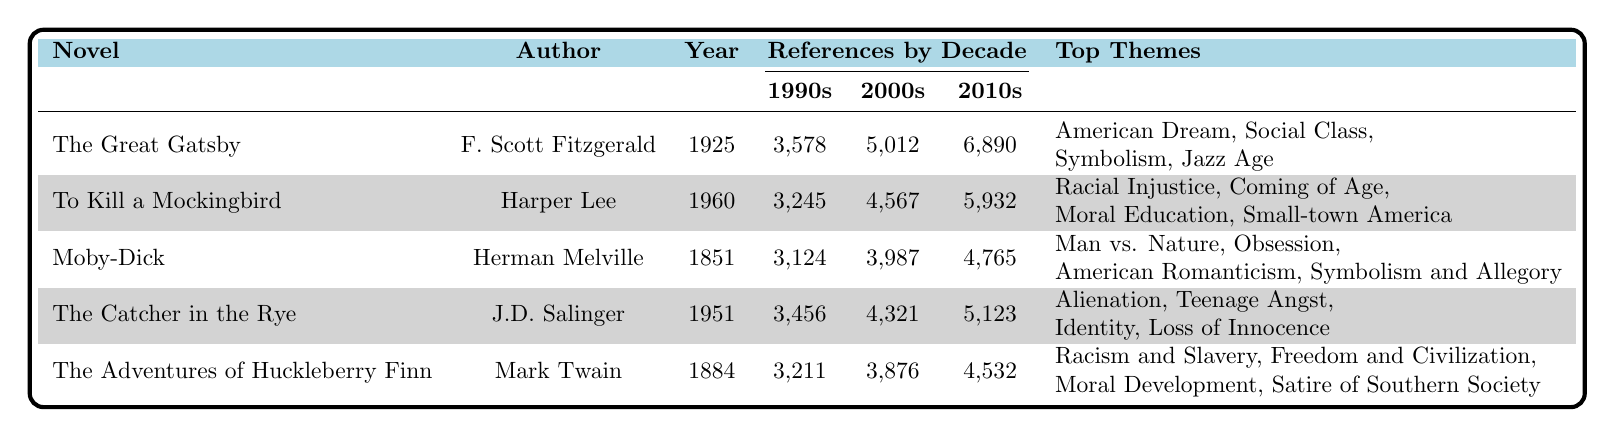What is the title of the novel with the most references in the 2010s? By examining the "References by Decade" section for the 2010s, "The Great Gatsby" has the highest count with 6,890 academic papers referencing it.
Answer: The Great Gatsby Which novel had the fewest references in the 1970s? Looking at the 1970s references, "To Kill a Mockingbird" had 987 academic papers, which is the lowest compared to the other novels listed.
Answer: To Kill a Mockingbird What are the top themes analyzed for "Moby-Dick"? Under the "Top Themes Analyzed" for "Moby-Dick," they include "Man vs. Nature," "Obsession," "American Romanticism," and "Symbolism and Allegory."
Answer: Man vs. Nature, Obsession, American Romanticism, Symbolism and Allegory How many more references did "To Kill a Mockingbird" receive in the 1990s than in the 1970s? In the 1990s, "To Kill a Mockingbird" had 3,245 academic papers compared to 987 in the 1970s. Therefore, the difference is 3,245 - 987 = 2,258.
Answer: 2258 Which novel experienced the highest increase in references from the 1990s to the 2010s? The increase for each novel can be calculated as follows: "The Great Gatsby" (6,890 - 3,578 = 3,312), "To Kill a Mockingbird" (5,932 - 3,245 = 2,687), "Moby-Dick" (4,765 - 3,124 = 1,641), "The Catcher in the Rye" (5,123 - 3,456 = 1,667), and "The Adventures of Huckleberry Finn" (4,532 - 3,211 = 1,321). "The Great Gatsby" had the highest increase of 3,312 references.
Answer: The Great Gatsby What is the total number of academic references for "The Catcher in the Rye" across all decades? Summing up the references from each decade gives: 3,456 + 4,321 + 5,123 = 12,900 academic papers for "The Catcher in the Rye."
Answer: 12,900 Is the theme "Racial Injustice" analyzed in "Moby-Dick"? The analyzed themes for "Moby-Dick" do not include "Racial Injustice," as the themes are focused on nature, obsession, and romanticism.
Answer: No Which author's works received more references in the 2010s, Harpers Lee or J.D. Salinger? Looking at the references for the 2010s, Harper Lee had 5,932 references, while J.D. Salinger had 5,123. Since 5,932 > 5,123, Harper Lee's works received more references.
Answer: Harper Lee 